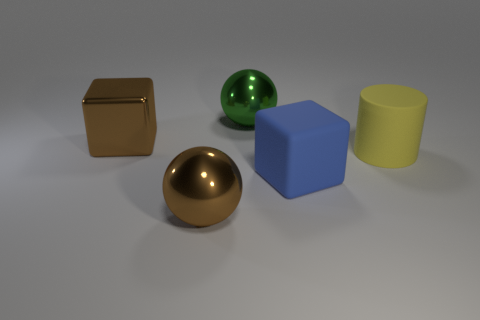Are there more yellow rubber cylinders than red cubes?
Keep it short and to the point. Yes. Do the brown metal object in front of the blue rubber block and the blue matte cube have the same size?
Your answer should be compact. Yes. How many rubber cylinders are the same color as the big metal block?
Make the answer very short. 0. Are there more large cubes that are to the left of the blue object than metal balls that are behind the big green ball?
Your answer should be very brief. Yes. Is the material of the yellow cylinder the same as the block that is right of the big green thing?
Provide a succinct answer. Yes. Are there any other things that are the same shape as the yellow matte object?
Keep it short and to the point. No. There is a large thing that is both in front of the brown metal block and behind the big blue rubber object; what color is it?
Give a very brief answer. Yellow. There is a big object in front of the rubber cube; what shape is it?
Offer a very short reply. Sphere. How big is the brown thing right of the large block that is on the left side of the metallic sphere that is left of the big green shiny ball?
Ensure brevity in your answer.  Large. How many big brown metal objects are behind the shiny ball that is in front of the rubber cube?
Your answer should be very brief. 1. 